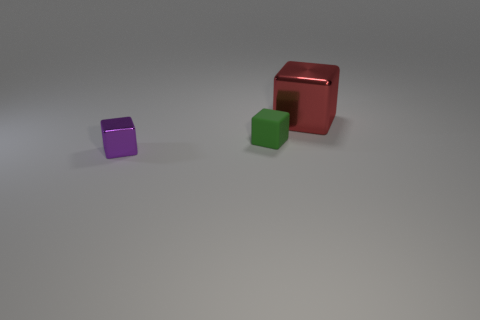Are there any other things that are the same material as the small green cube?
Give a very brief answer. No. Are any small cyan matte spheres visible?
Give a very brief answer. No. There is a green object that is the same shape as the purple thing; what is it made of?
Your response must be concise. Rubber. There is a red block behind the small thing behind the block in front of the tiny green object; what is its size?
Keep it short and to the point. Large. Are there any red cubes to the left of the tiny green block?
Offer a very short reply. No. What size is the red thing that is made of the same material as the small purple cube?
Give a very brief answer. Large. How many other large red metal objects have the same shape as the large metallic thing?
Provide a short and direct response. 0. Is the red thing made of the same material as the small object that is to the right of the tiny purple block?
Make the answer very short. No. Are there more tiny purple objects that are in front of the big block than tiny blue balls?
Provide a succinct answer. Yes. Is there a purple object made of the same material as the big red cube?
Provide a short and direct response. Yes. 